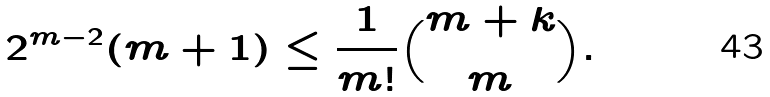<formula> <loc_0><loc_0><loc_500><loc_500>2 ^ { m - 2 } ( m + 1 ) \leq \frac { 1 } { m ! } { m + k \choose m } .</formula> 